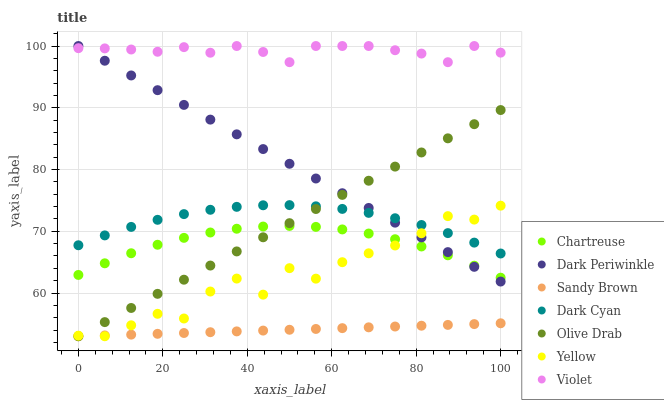Does Sandy Brown have the minimum area under the curve?
Answer yes or no. Yes. Does Violet have the maximum area under the curve?
Answer yes or no. Yes. Does Chartreuse have the minimum area under the curve?
Answer yes or no. No. Does Chartreuse have the maximum area under the curve?
Answer yes or no. No. Is Sandy Brown the smoothest?
Answer yes or no. Yes. Is Yellow the roughest?
Answer yes or no. Yes. Is Chartreuse the smoothest?
Answer yes or no. No. Is Chartreuse the roughest?
Answer yes or no. No. Does Yellow have the lowest value?
Answer yes or no. Yes. Does Chartreuse have the lowest value?
Answer yes or no. No. Does Dark Periwinkle have the highest value?
Answer yes or no. Yes. Does Chartreuse have the highest value?
Answer yes or no. No. Is Olive Drab less than Violet?
Answer yes or no. Yes. Is Violet greater than Sandy Brown?
Answer yes or no. Yes. Does Yellow intersect Dark Periwinkle?
Answer yes or no. Yes. Is Yellow less than Dark Periwinkle?
Answer yes or no. No. Is Yellow greater than Dark Periwinkle?
Answer yes or no. No. Does Olive Drab intersect Violet?
Answer yes or no. No. 